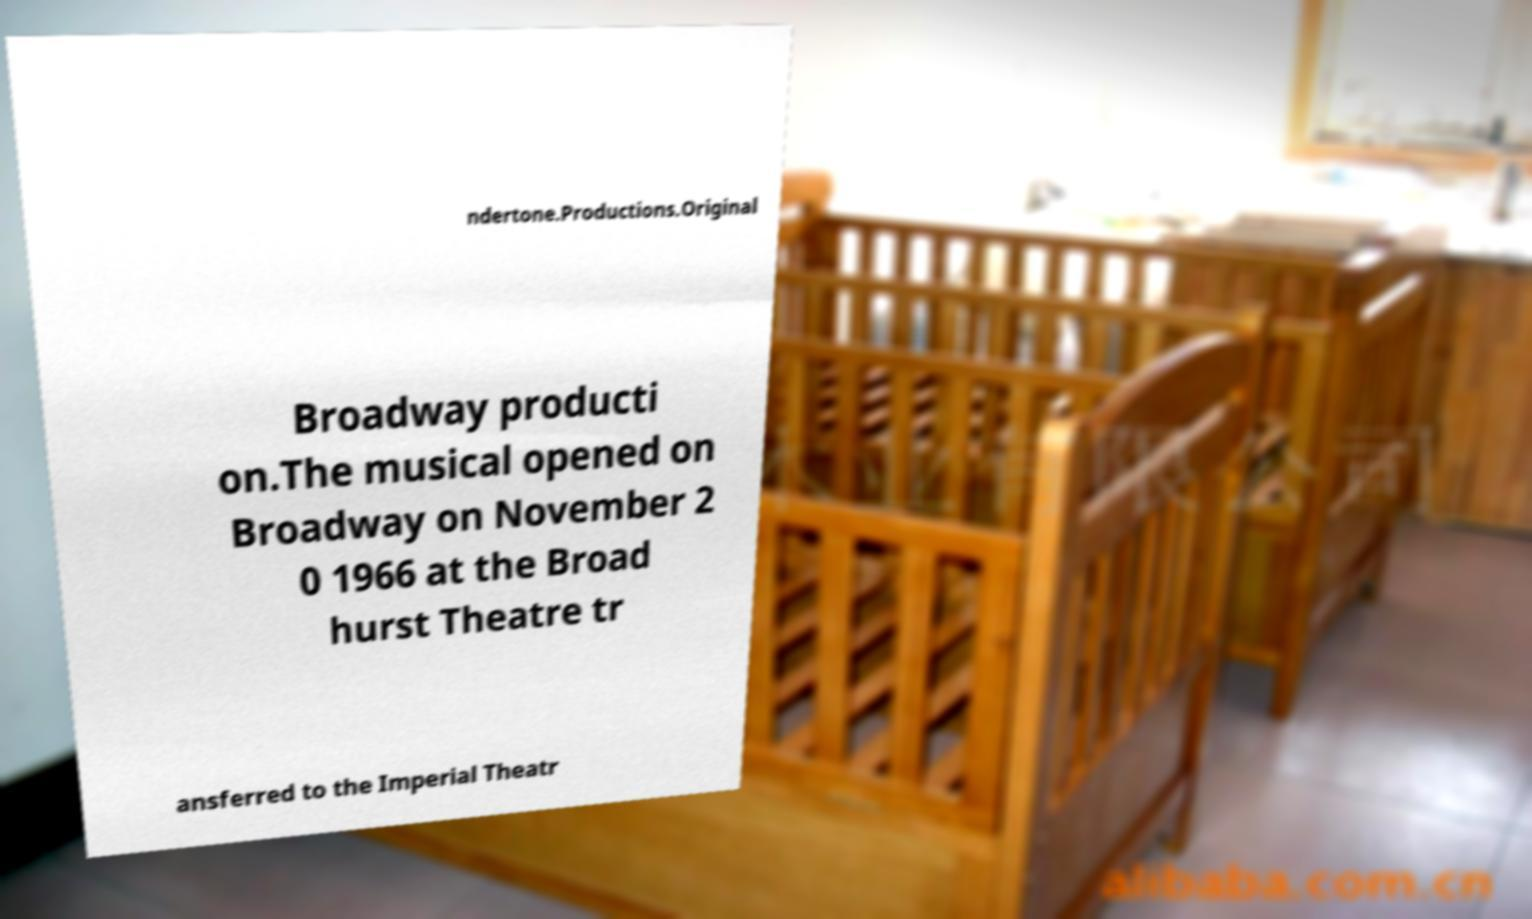Please identify and transcribe the text found in this image. ndertone.Productions.Original Broadway producti on.The musical opened on Broadway on November 2 0 1966 at the Broad hurst Theatre tr ansferred to the Imperial Theatr 